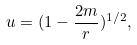Convert formula to latex. <formula><loc_0><loc_0><loc_500><loc_500>u = ( 1 - \frac { 2 m } { r } ) ^ { 1 / 2 } ,</formula> 